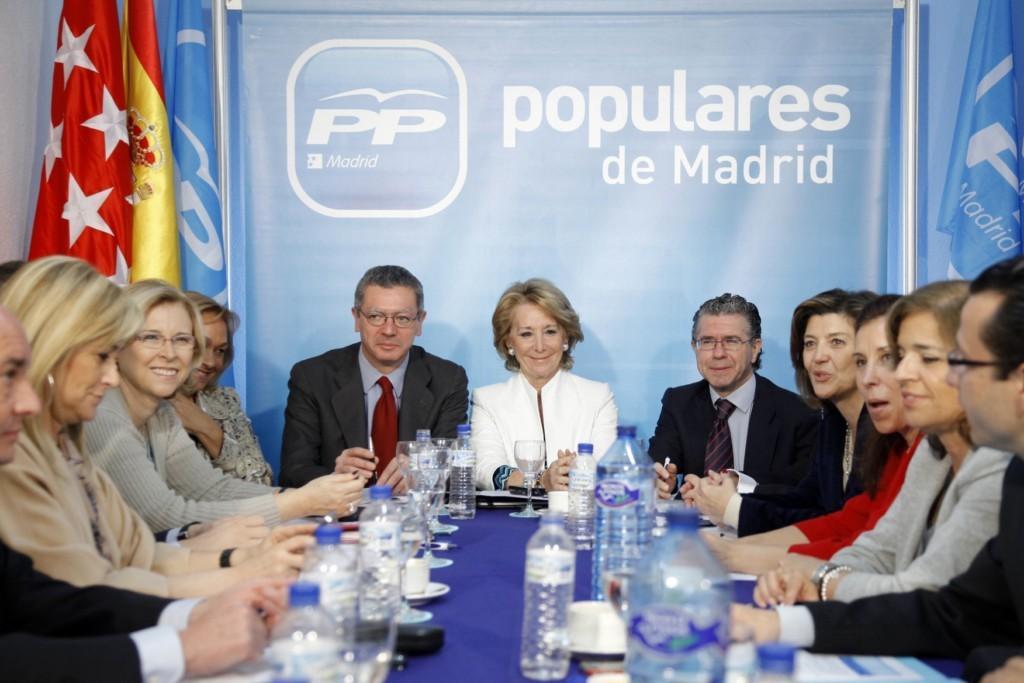How would you summarize this image in a sentence or two? In this image there are people sitting on the chairs at the table. On the table there are water bottles, cup and saucers and wine glasses. Behind them there is a banner. There is text on the banner. On the either sides of the image there are flags. 